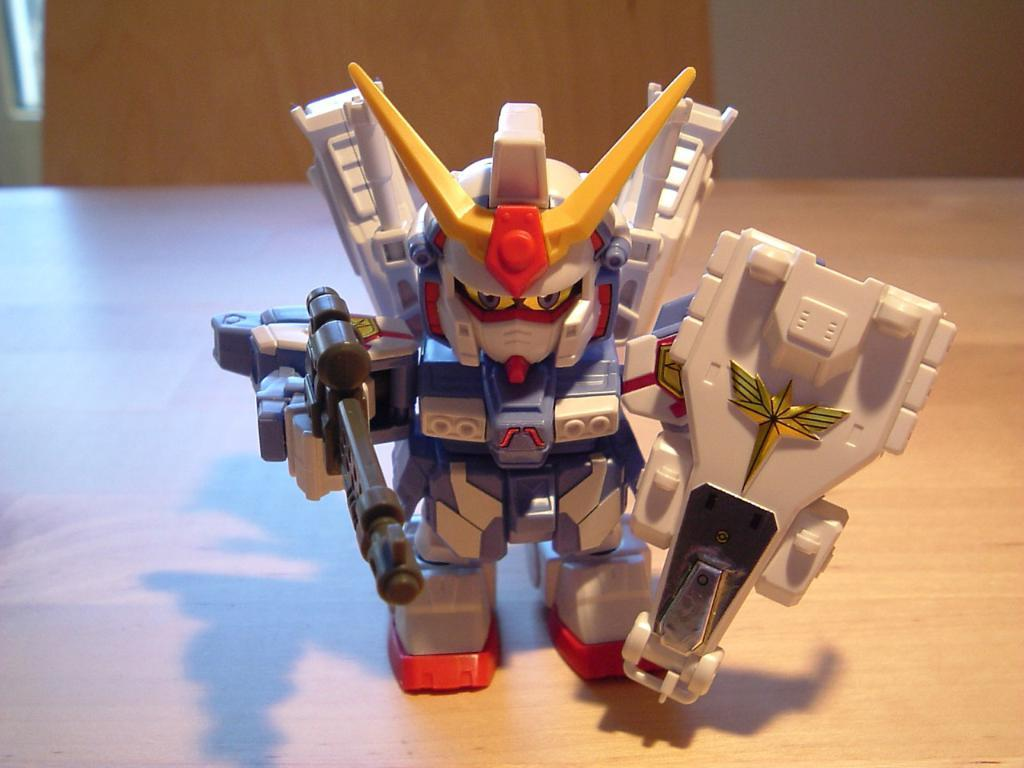What is the main subject of the image? The main subject of the image is a toy robot. Where is the toy robot located? The toy robot is on a wooden board. What type of pancake is the toy robot flipping in the image? There is no pancake present in the image, and the toy robot is not flipping anything. 